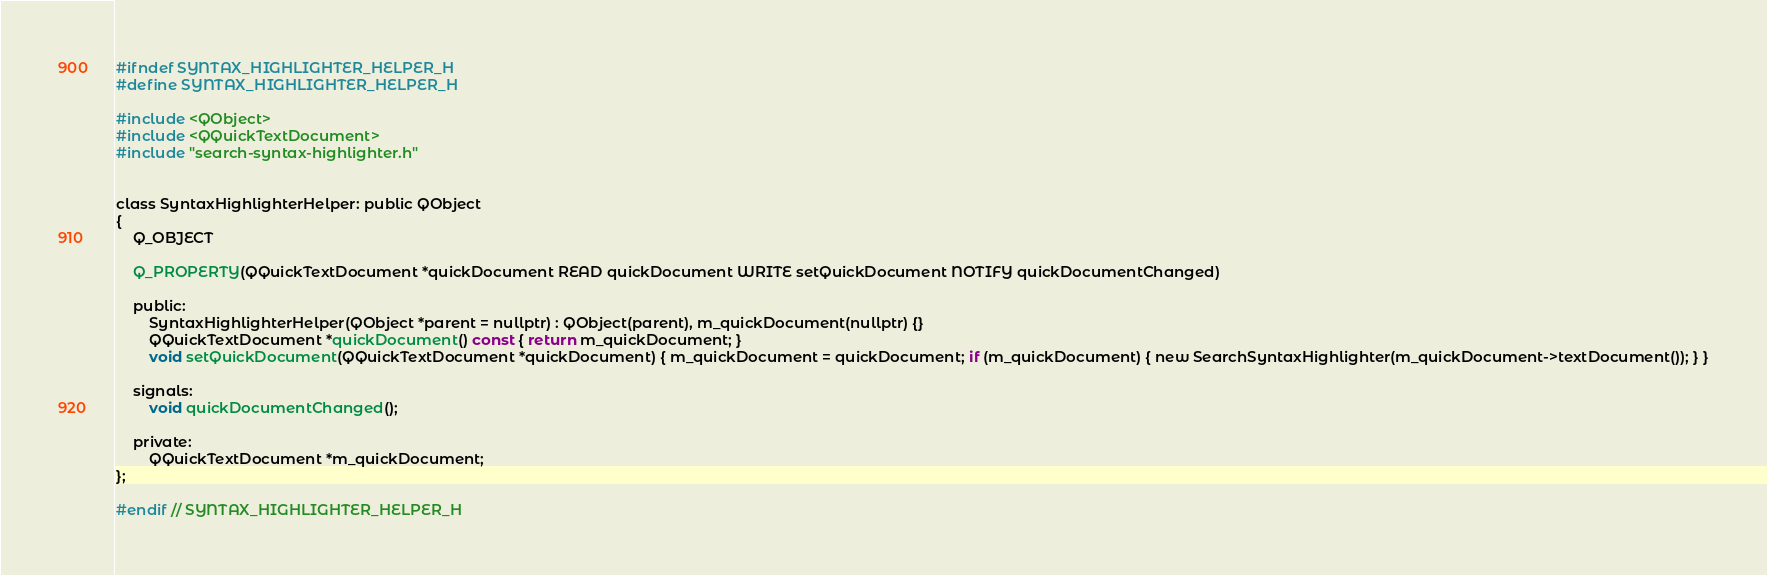<code> <loc_0><loc_0><loc_500><loc_500><_C_>#ifndef SYNTAX_HIGHLIGHTER_HELPER_H
#define SYNTAX_HIGHLIGHTER_HELPER_H

#include <QObject>
#include <QQuickTextDocument>
#include "search-syntax-highlighter.h"


class SyntaxHighlighterHelper: public QObject
{
    Q_OBJECT

	Q_PROPERTY(QQuickTextDocument *quickDocument READ quickDocument WRITE setQuickDocument NOTIFY quickDocumentChanged)

    public:
        SyntaxHighlighterHelper(QObject *parent = nullptr) : QObject(parent), m_quickDocument(nullptr) {}
        QQuickTextDocument *quickDocument() const { return m_quickDocument; }
        void setQuickDocument(QQuickTextDocument *quickDocument) { m_quickDocument = quickDocument; if (m_quickDocument) { new SearchSyntaxHighlighter(m_quickDocument->textDocument()); } }

    signals:
        void quickDocumentChanged();

    private:
        QQuickTextDocument *m_quickDocument;
};

#endif // SYNTAX_HIGHLIGHTER_HELPER_H
</code> 